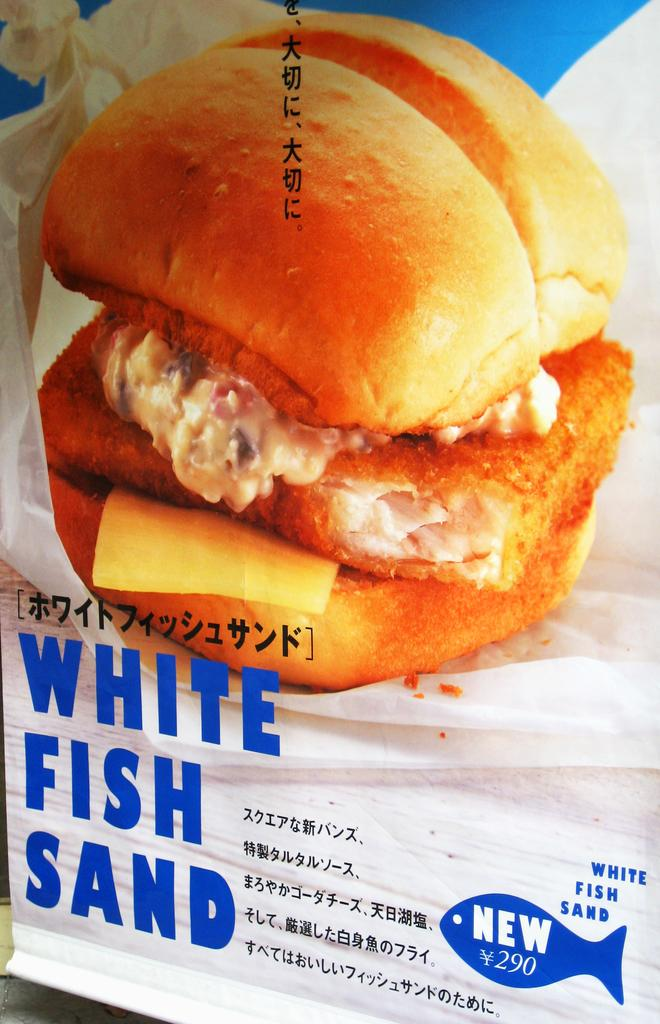What type of food is visible in the image? There is a burger in the image. What other object can be seen in the image besides the burger? There is a white color paper in the image. What type of laborer is working in the image? There is no laborer present in the image. How can you tell if the burger is quiet in the image? The concept of a burger being quiet is not applicable, as it is an inanimate object and cannot make noise. 